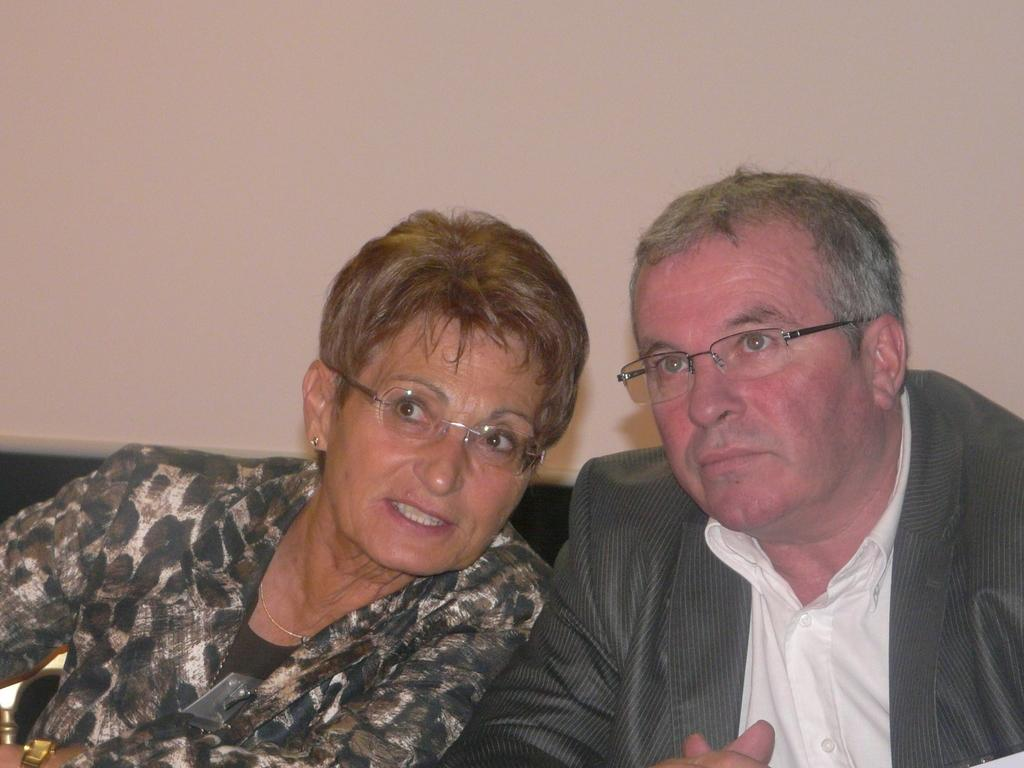How many people are present in the image? There are two people, a man and a woman, present in the image. What are the people in the image wearing? Both the man and woman are wearing clothes. Can you describe the woman's accessories in the image? The woman is wearing spectacles, a neck chain, and ear studs. She is also holding a bracelet in her hand. What is visible in the background of the image? There is a wall in the image. What type of soup is the man eating in the image? There is no soup present in the image; the man is not eating anything. How many buttons can be seen on the woman's shirt in the image? There is no information about the woman's shirt or buttons in the image. 